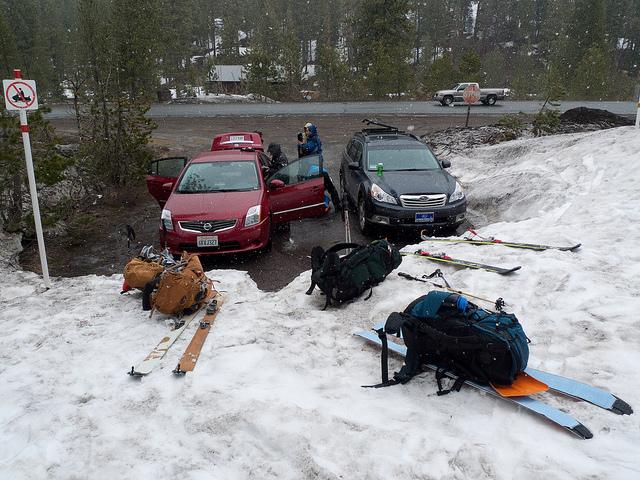What sort of outing are they embarking on?

Choices:
A) skiing
B) snowboarding
C) camping
D) beach skiing 